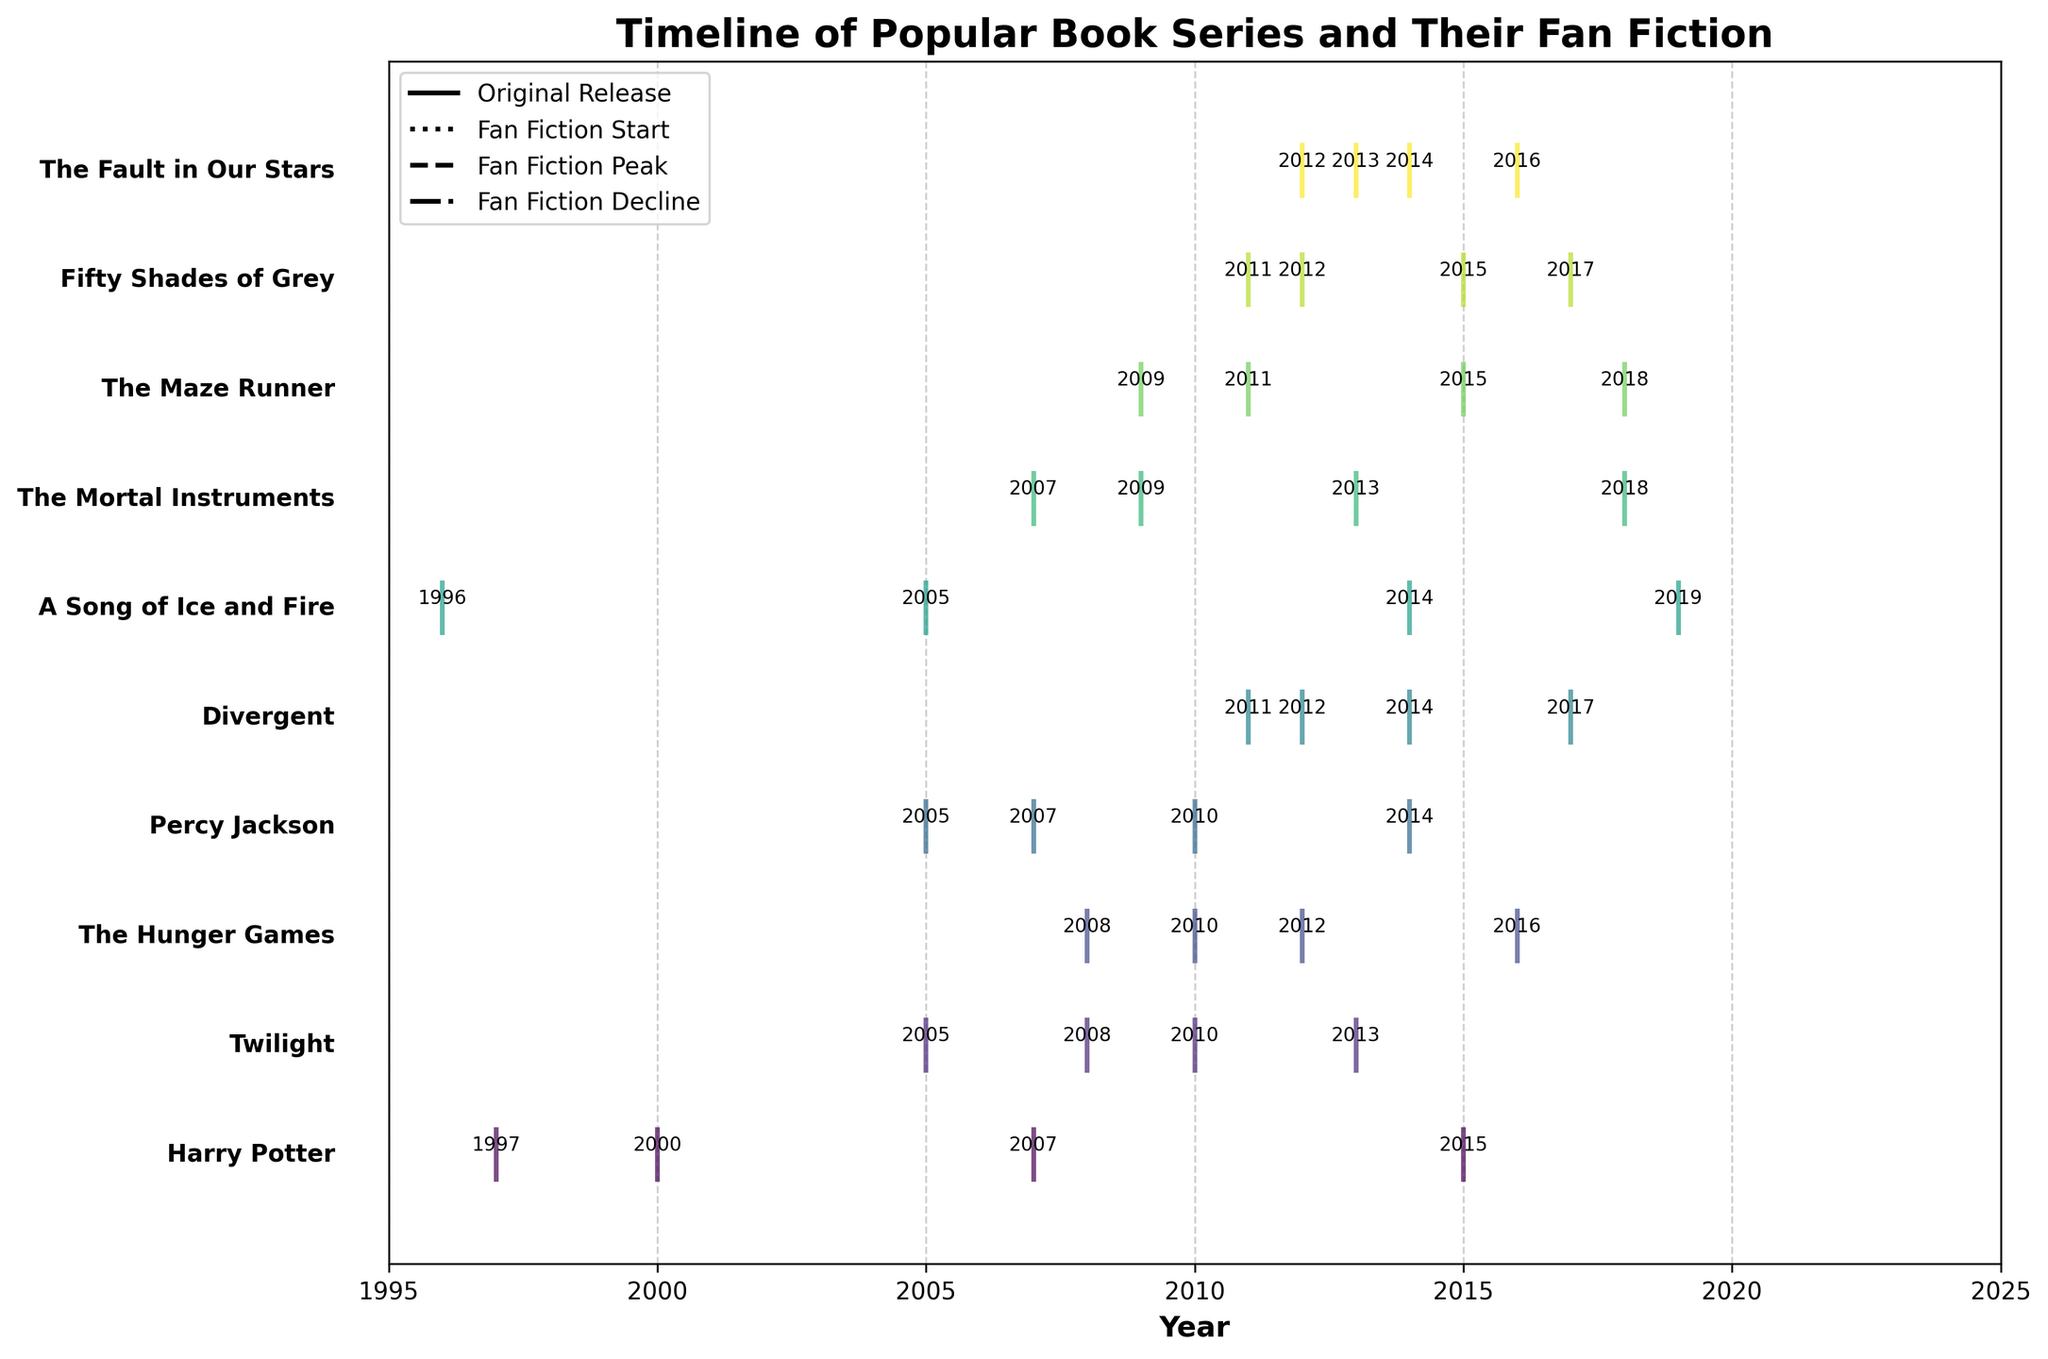What is the title of the plot? The title of the plot is usually found at the top and often summarizes the content of the figure. In this case, the title is "Timeline of Popular Book Series and Their Fan Fiction".
Answer: Timeline of Popular Book Series and Their Fan Fiction What is the y-axis showing? The y-axis typically labels the categories being plotted. Here, it shows the names of popular book series such as "Harry Potter", "Twilight", etc., indicating the timeline for each series and its fan fiction.
Answer: The names of popular book series When did the fan fiction for "Twilight" start? Find "Twilight" on the y-axis and follow the vertical line to where the 'start' event marking is placed. The corresponding year on the x-axis is the fan fiction start year. For "Twilight", it's in 2008.
Answer: 2008 Which series had fan fiction that peaked in 2010? Look for the event marking on the x-axis at the year 2010 and identify which series it aligns with. Among the series, "Twilight" and "Percy Jackson" show peaks in 2010.
Answer: Twilight and Percy Jackson How many years after its original release did "The Fault in Our Stars" have its fan fiction peak? First, find the original release year (2012) and the fan fiction peak year (2014) for "The Fault in Our Stars." Calculate the difference: 2014 - 2012 = 2 years.
Answer: 2 years Which series had the longest delay between the original release and the start of fan fiction? Calculate the difference between the original release year and the fan fiction start year for each series. "A Song of Ice and Fire" had its original release in 1996, and fan fiction started in 2005, giving a gap of 9 years.
Answer: A Song of Ice and Fire Arrange the series' original release years in chronological order. Identify and list the original release years in ascending order: "A Song of Ice and Fire" (1996), "Harry Potter" (1997), "Twilight" (2005), "Percy Jackson" (2005), etc. Continue for all series.
Answer: A Song of Ice and Fire, Harry Potter, Twilight, Percy Jackson, The Mortal Instruments, The Maze Runner, The Hunger Games, Divergent, Fifty Shades of Grey, The Fault in Our Stars Which series experienced a decline in fan fiction the latest? Look for the 'decline' event markings and identify the latest year. The latest decline year is 2019 for "A Song of Ice and Fire."
Answer: A Song of Ice and Fire What’s the time span between the fan fiction start and decline for "The Hunger Games"? Find the fan fiction start year (2010) and decline year (2016) for "The Hunger Games" and calculate the difference: 2016 - 2010 = 6 years.
Answer: 6 years 